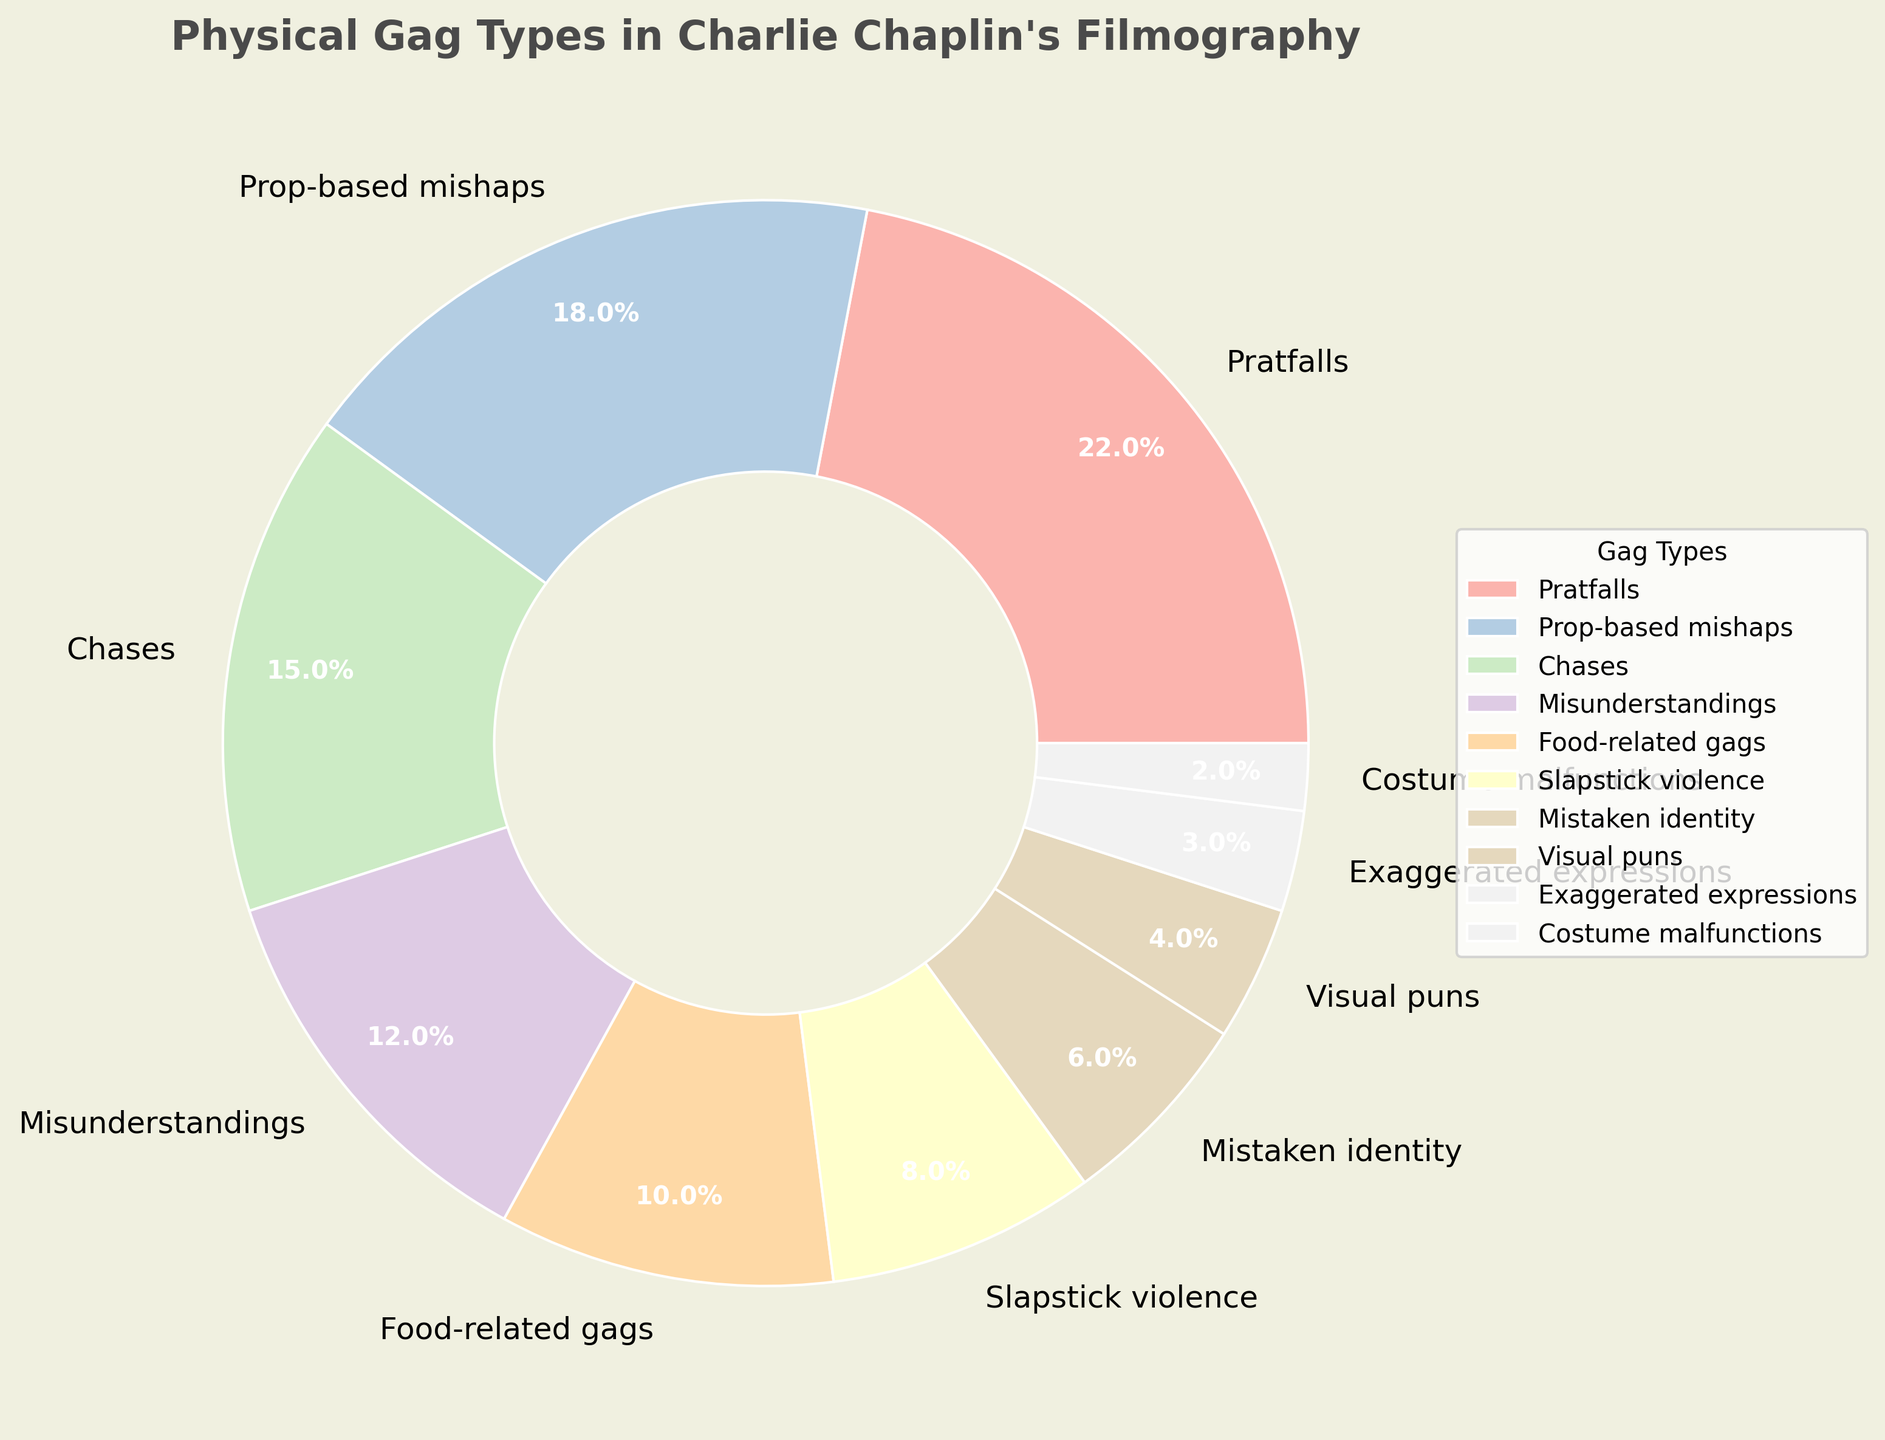Which gag type appears most frequently in Charlie Chaplin's filmography? The largest wedge in the pie chart represents the gag type that appears most frequently. Here, the largest wedge is labeled "Pratfalls."
Answer: Pratfalls What is the total percentage of gag types involving misunderstandings and mistaken identity? To find the total, sum the percentages for "Misunderstandings" and "Mistaken identity." According to the chart, these are 12% and 6% respectively. 12% + 6% = 18%.
Answer: 18% Is the percentage of food-related gags greater than that of slapstick violence? Compare the percentage values for "Food-related gags" and "Slapstick violence." "Food-related gags" is 10% while "Slapstick violence" is 8%. Since 10% is greater than 8%, the answer is yes.
Answer: Yes What is the combined percentage for visual puns, exaggerated expressions, and costume malfunctions? To find the combined percentage, add the values for "Visual puns" (4%), "Exaggerated expressions" (3%), and "Costume malfunctions" (2%). 4% + 3% + 2% = 9%.
Answer: 9% How does the percentage of prop-based mishaps compare to the percentage of chases? Compare the percentage values for "Prop-based mishaps" and "Chases." "Prop-based mishaps" is 18%, while "Chases" is 15%. Since 18% is greater than 15%, the percentage of prop-based mishaps is higher.
Answer: Prop-based mishaps are higher Which gag types have percentages below 5%? Identify the wedges in the pie chart with percentages below 5%. These are "Visual puns" (4%), "Exaggerated expressions" (3%), and "Costume malfunctions" (2%).
Answer: Visual puns, Exaggerated expressions, Costume malfunctions What is the difference in percentage between pratfalls and misunderstandings? Subtract the percentage of "Misunderstandings" from the percentage of "Pratfalls." 22% - 12% = 10%.
Answer: 10% Which gag type is represented by the smallest wedge? The smallest wedge in the pie chart corresponds to the gag type with the smallest percentage. Here, it is "Costume malfunctions" with 2%.
Answer: Costume malfunctions By how much does the percentage of prop-based mishaps exceed that of mistaken identity and exaggerated expressions combined? First, sum the percentages for "Mistaken identity" and "Exaggerated expressions": 6% + 3% = 9%. Then, subtract this total from the percentage for "Prop-based mishaps" (18%). 18% - 9% = 9%.
Answer: 9% 